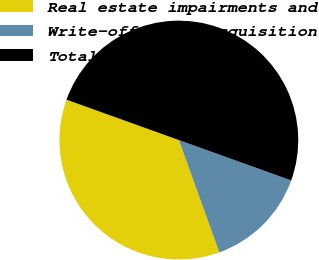Convert chart. <chart><loc_0><loc_0><loc_500><loc_500><pie_chart><fcel>Real estate impairments and<fcel>Write-off of preacquisition<fcel>Total<nl><fcel>36.0%<fcel>14.0%<fcel>50.0%<nl></chart> 